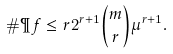<formula> <loc_0><loc_0><loc_500><loc_500>\# \P f \leq r 2 ^ { r + 1 } \binom { m } { r } \mu ^ { r + 1 } .</formula> 